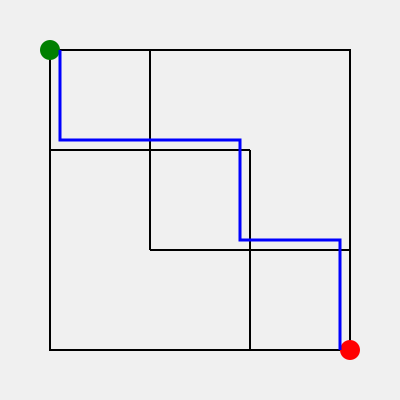In the dealership lot maze shown above, what is the minimum number of 90-degree turns required to navigate from the green starting point (top-left) to the red endpoint (bottom-right) while following the blue path? To solve this problem, we need to follow the blue path and count the number of 90-degree turns:

1. The path starts at the green point (top-left).
2. It moves right, then makes a 90-degree turn downward. Turn count: 1
3. It continues down, then makes a 90-degree turn to the right. Turn count: 2
4. It moves right, then makes another 90-degree turn downward. Turn count: 3
5. It continues down, then makes a final 90-degree turn to the right. Turn count: 4
6. The path ends at the red point (bottom-right).

Each 90-degree turn represents a change in direction, either from vertical to horizontal or vice versa. The blue path clearly shows 4 such turns.

It's worth noting that this path is optimal as it avoids any unnecessary turns or backtracking, utilizing the available space efficiently to reach the endpoint.
Answer: 4 turns 